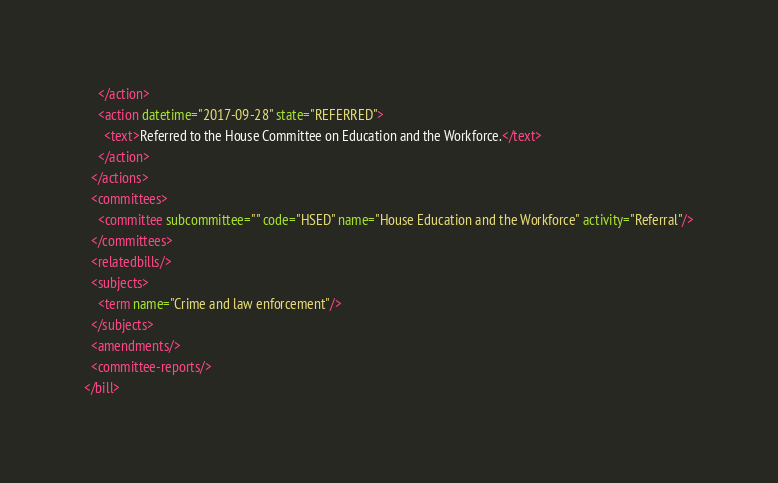Convert code to text. <code><loc_0><loc_0><loc_500><loc_500><_XML_>    </action>
    <action datetime="2017-09-28" state="REFERRED">
      <text>Referred to the House Committee on Education and the Workforce.</text>
    </action>
  </actions>
  <committees>
    <committee subcommittee="" code="HSED" name="House Education and the Workforce" activity="Referral"/>
  </committees>
  <relatedbills/>
  <subjects>
    <term name="Crime and law enforcement"/>
  </subjects>
  <amendments/>
  <committee-reports/>
</bill>
</code> 